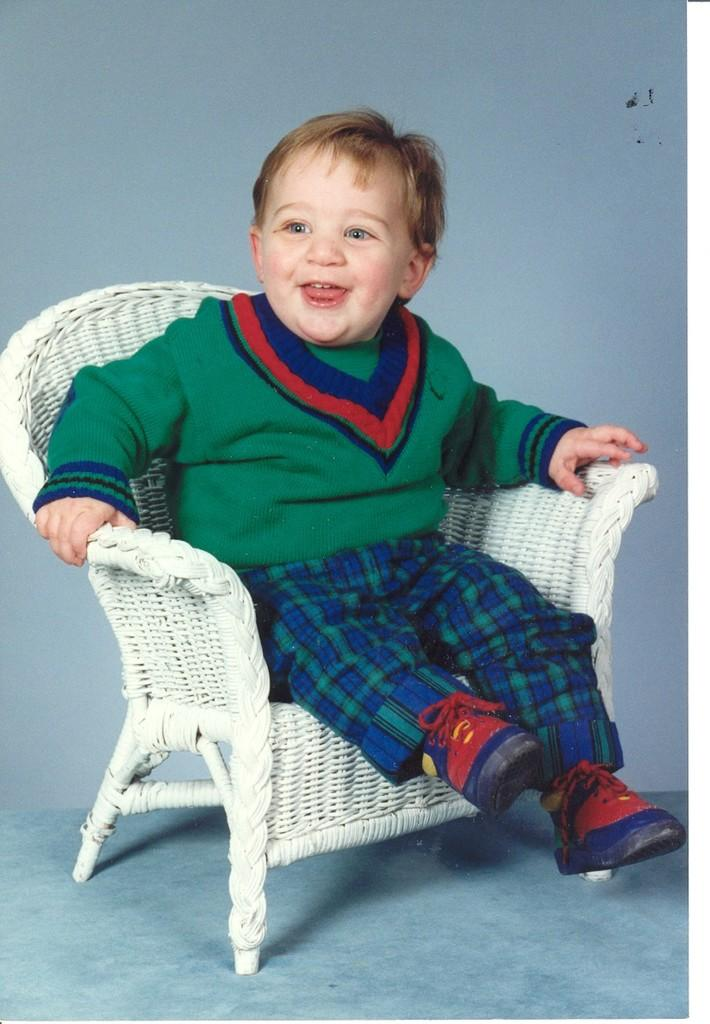What is the main subject of the image? The main subject of the subject of the image is a kid. What is the kid doing in the image? The kid is sitting on a chair and smiling. What can be seen in the background of the image? There is a wall in the background of the image. What type of dog can be seen interacting with the kid in the image? There is no dog present in the image; the main subject is a kid sitting on a chair and smiling. Can you tell me how the moon affects the kid's mood in the image? The moon is not visible in the image, and therefore its effect on the kid's mood cannot be determined. 